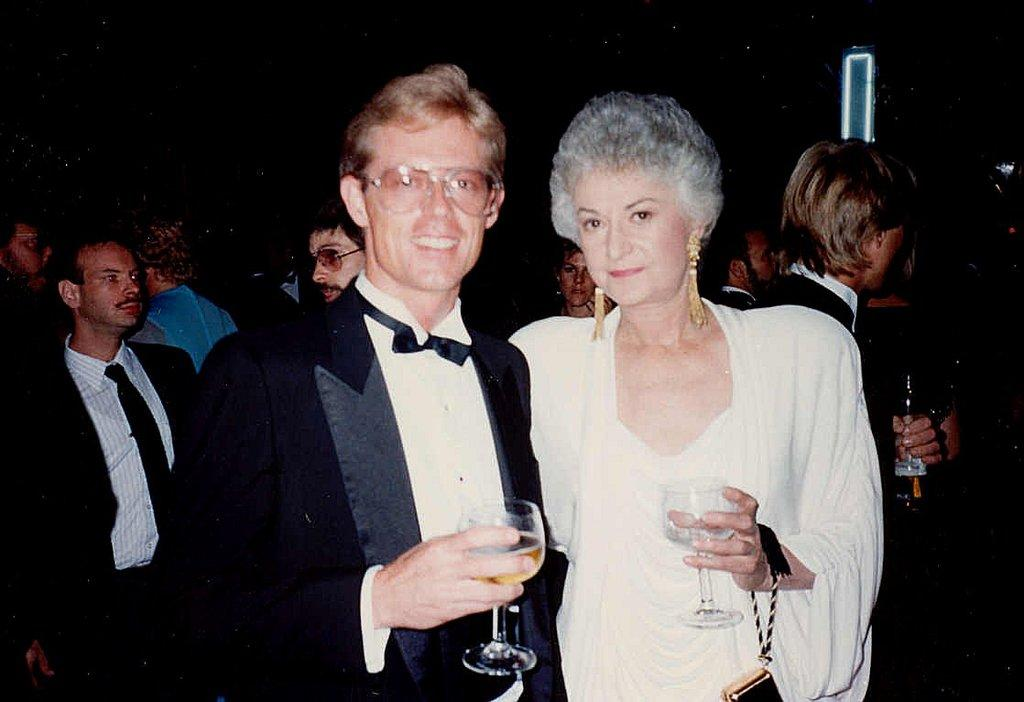What is the main subject of the image? The main subject of the image is a group of people. What are some of the people in the group doing? Some people in the group are standing. What objects are being held by some of the people in the group? There are people holding wine glasses in their hands. What type of ducks can be seen swimming in the side downtown in the image? There are no ducks present in the image, and therefore no such activity can be observed. 